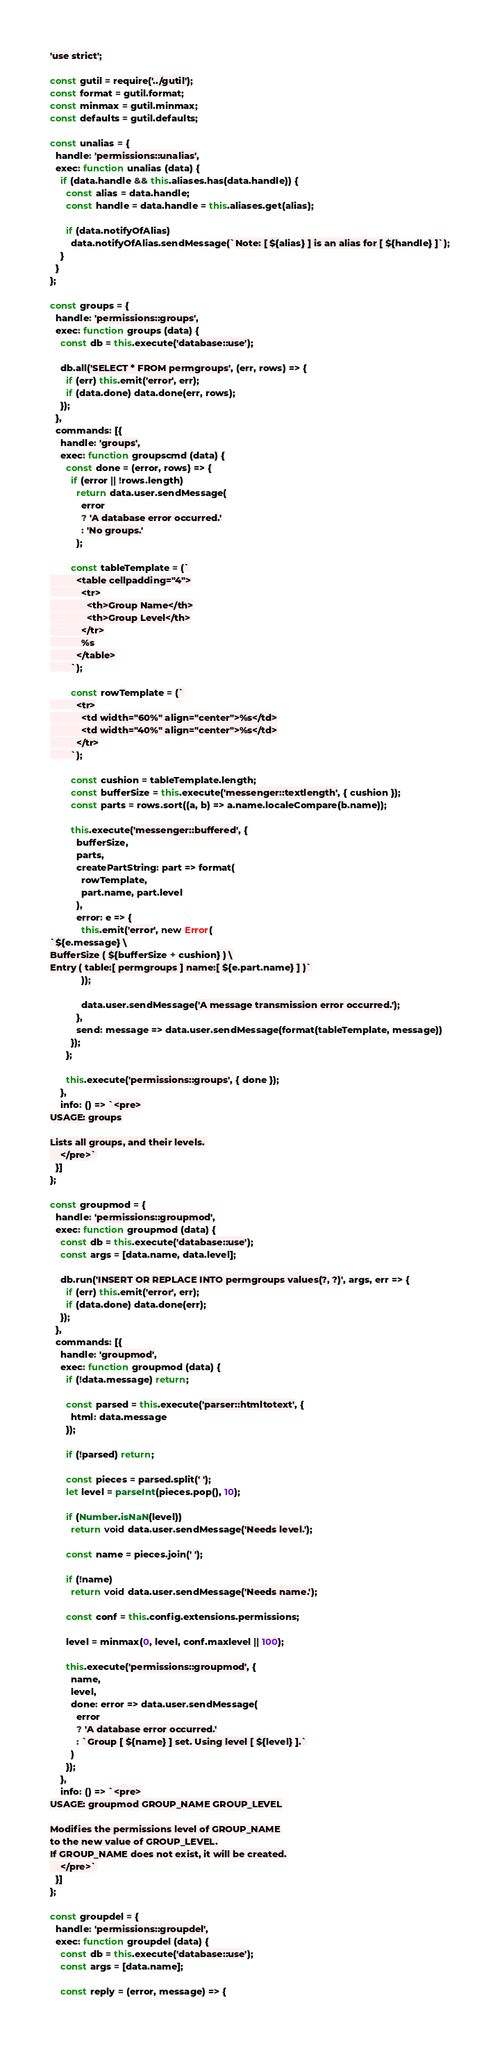<code> <loc_0><loc_0><loc_500><loc_500><_JavaScript_>'use strict';

const gutil = require('../gutil');
const format = gutil.format;
const minmax = gutil.minmax;
const defaults = gutil.defaults;

const unalias = {
  handle: 'permissions::unalias',
  exec: function unalias (data) {
    if (data.handle && this.aliases.has(data.handle)) {
      const alias = data.handle;
      const handle = data.handle = this.aliases.get(alias);

      if (data.notifyOfAlias)
        data.notifyOfAlias.sendMessage(`Note: [ ${alias} ] is an alias for [ ${handle} ]`);
    }
  }
};

const groups = {
  handle: 'permissions::groups',
  exec: function groups (data) {
    const db = this.execute('database::use');

    db.all('SELECT * FROM permgroups', (err, rows) => {
      if (err) this.emit('error', err);
      if (data.done) data.done(err, rows);
    });
  },
  commands: [{
    handle: 'groups',
    exec: function groupscmd (data) {
      const done = (error, rows) => {
        if (error || !rows.length)
          return data.user.sendMessage(
            error
            ? 'A database error occurred.'
            : 'No groups.'
          );

        const tableTemplate = (`
          <table cellpadding="4">
            <tr>
              <th>Group Name</th>
              <th>Group Level</th>
            </tr>
            %s
          </table>
        `);

        const rowTemplate = (`
          <tr>
            <td width="60%" align="center">%s</td>
            <td width="40%" align="center">%s</td>
          </tr>
        `);

        const cushion = tableTemplate.length;
        const bufferSize = this.execute('messenger::textlength', { cushion });
        const parts = rows.sort((a, b) => a.name.localeCompare(b.name));

        this.execute('messenger::buffered', {
          bufferSize,
          parts,
          createPartString: part => format(
            rowTemplate,
            part.name, part.level
          ),
          error: e => {
            this.emit('error', new Error(
`${e.message} \
BufferSize ( ${bufferSize + cushion} ) \
Entry ( table:[ permgroups ] name:[ ${e.part.name} ] )`
            ));

            data.user.sendMessage('A message transmission error occurred.');
          },
          send: message => data.user.sendMessage(format(tableTemplate, message))
        });
      };

      this.execute('permissions::groups', { done });
    },
    info: () => `<pre>
USAGE: groups

Lists all groups, and their levels.
    </pre>`
  }]
};

const groupmod = {
  handle: 'permissions::groupmod',
  exec: function groupmod (data) {
    const db = this.execute('database::use');
    const args = [data.name, data.level];

    db.run('INSERT OR REPLACE INTO permgroups values(?, ?)', args, err => {
      if (err) this.emit('error', err);
      if (data.done) data.done(err);
    });
  },
  commands: [{
    handle: 'groupmod',
    exec: function groupmod (data) {
      if (!data.message) return;

      const parsed = this.execute('parser::htmltotext', {
        html: data.message
      });

      if (!parsed) return;

      const pieces = parsed.split(' ');
      let level = parseInt(pieces.pop(), 10);

      if (Number.isNaN(level))
        return void data.user.sendMessage('Needs level.');

      const name = pieces.join(' ');

      if (!name)
        return void data.user.sendMessage('Needs name.');

      const conf = this.config.extensions.permissions;

      level = minmax(0, level, conf.maxlevel || 100);

      this.execute('permissions::groupmod', {
        name,
        level,
        done: error => data.user.sendMessage(
          error
          ? 'A database error occurred.'
          : `Group [ ${name} ] set. Using level [ ${level} ].`
        )
      });
    },
    info: () => `<pre>
USAGE: groupmod GROUP_NAME GROUP_LEVEL

Modifies the permissions level of GROUP_NAME
to the new value of GROUP_LEVEL.
If GROUP_NAME does not exist, it will be created.
    </pre>`
  }]
};

const groupdel = {
  handle: 'permissions::groupdel',
  exec: function groupdel (data) {
    const db = this.execute('database::use');
    const args = [data.name];

    const reply = (error, message) => {</code> 